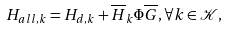Convert formula to latex. <formula><loc_0><loc_0><loc_500><loc_500>H _ { a l l , k } = H _ { d , k } + \overline { H } _ { k } \Phi \overline { G } , \forall k \in \mathcal { K } ,</formula> 